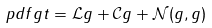<formula> <loc_0><loc_0><loc_500><loc_500>\ p d f { g } { t } = { \mathcal { L } } g + { \mathcal { C } } g + { \mathcal { N } } ( g , g )</formula> 